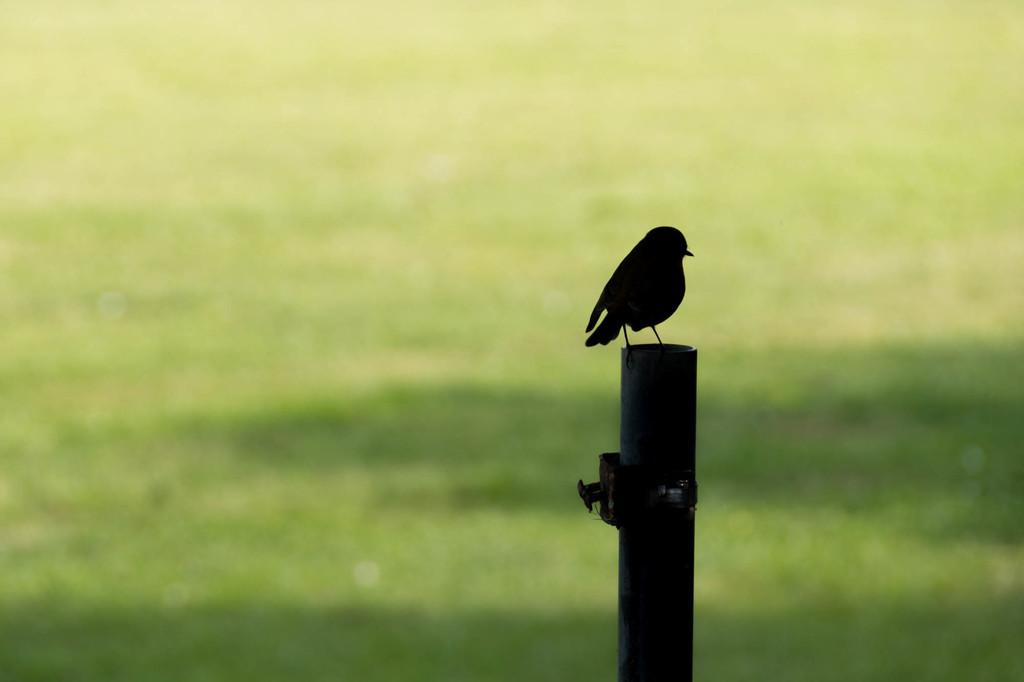What type of animal is in the image? There is a bird in the image. Where is the bird located? The bird is on a pole. Can you describe the background of the image? The background of the image is blurred, and the background color is green. What type of stem can be seen growing from the bird's head in the image? There is no stem growing from the bird's head in the image. What force is causing the bird to fly in the image? The image does not show the bird flying, so it is not possible to determine the force causing it to fly. 